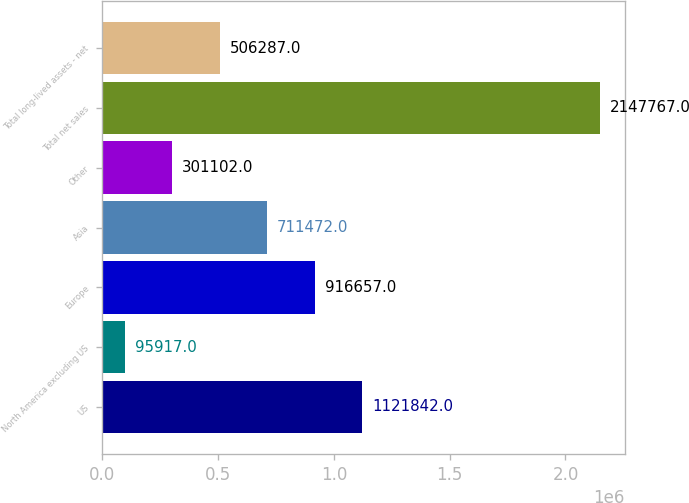<chart> <loc_0><loc_0><loc_500><loc_500><bar_chart><fcel>US<fcel>North America excluding US<fcel>Europe<fcel>Asia<fcel>Other<fcel>Total net sales<fcel>Total long-lived assets - net<nl><fcel>1.12184e+06<fcel>95917<fcel>916657<fcel>711472<fcel>301102<fcel>2.14777e+06<fcel>506287<nl></chart> 